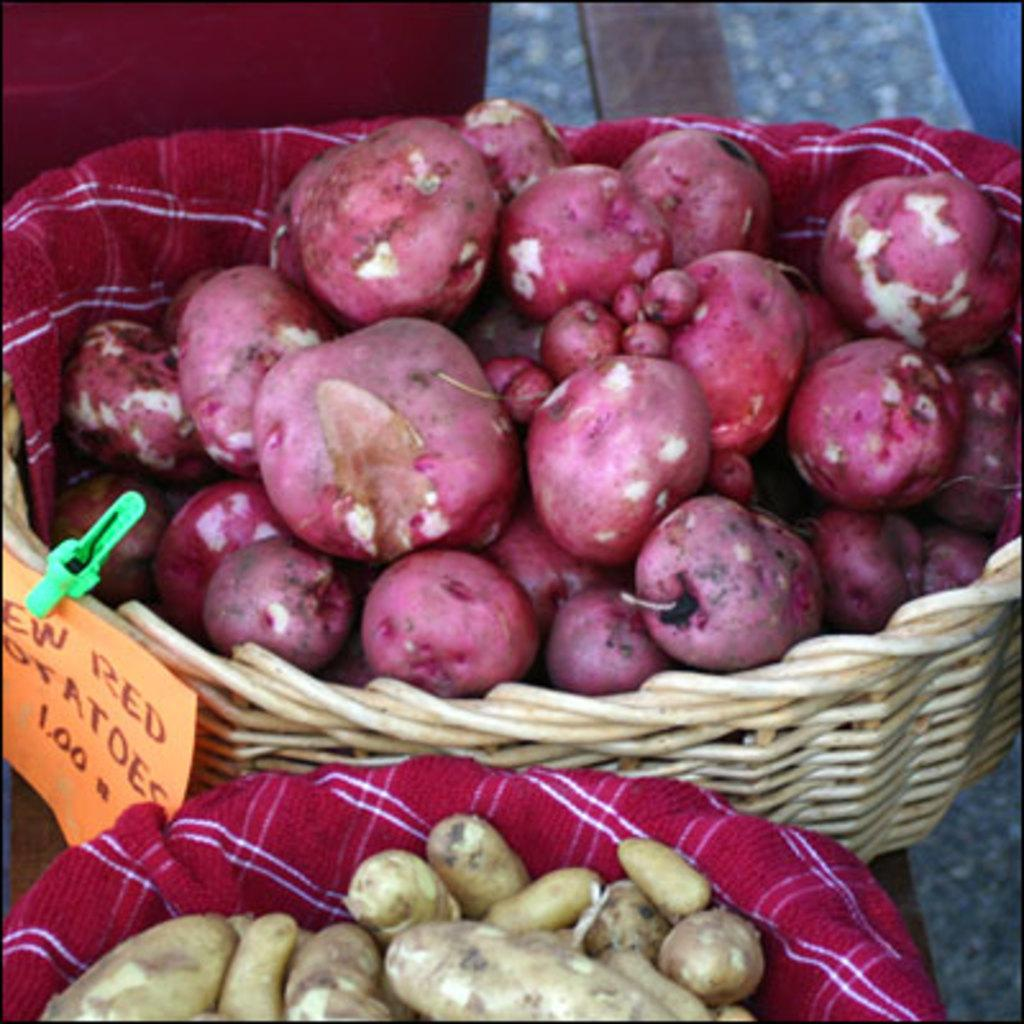What type of potatoes are in the image? There are red potatoes in the image. How are the red potatoes stored in the image? The red potatoes are in a basket. Where is the basket with the red potatoes located? The basket is kept on the floor. What type of insurance is required to start a red potato farm in the image? There is no mention of a red potato farm or insurance in the image, so it cannot be determined from the image. 